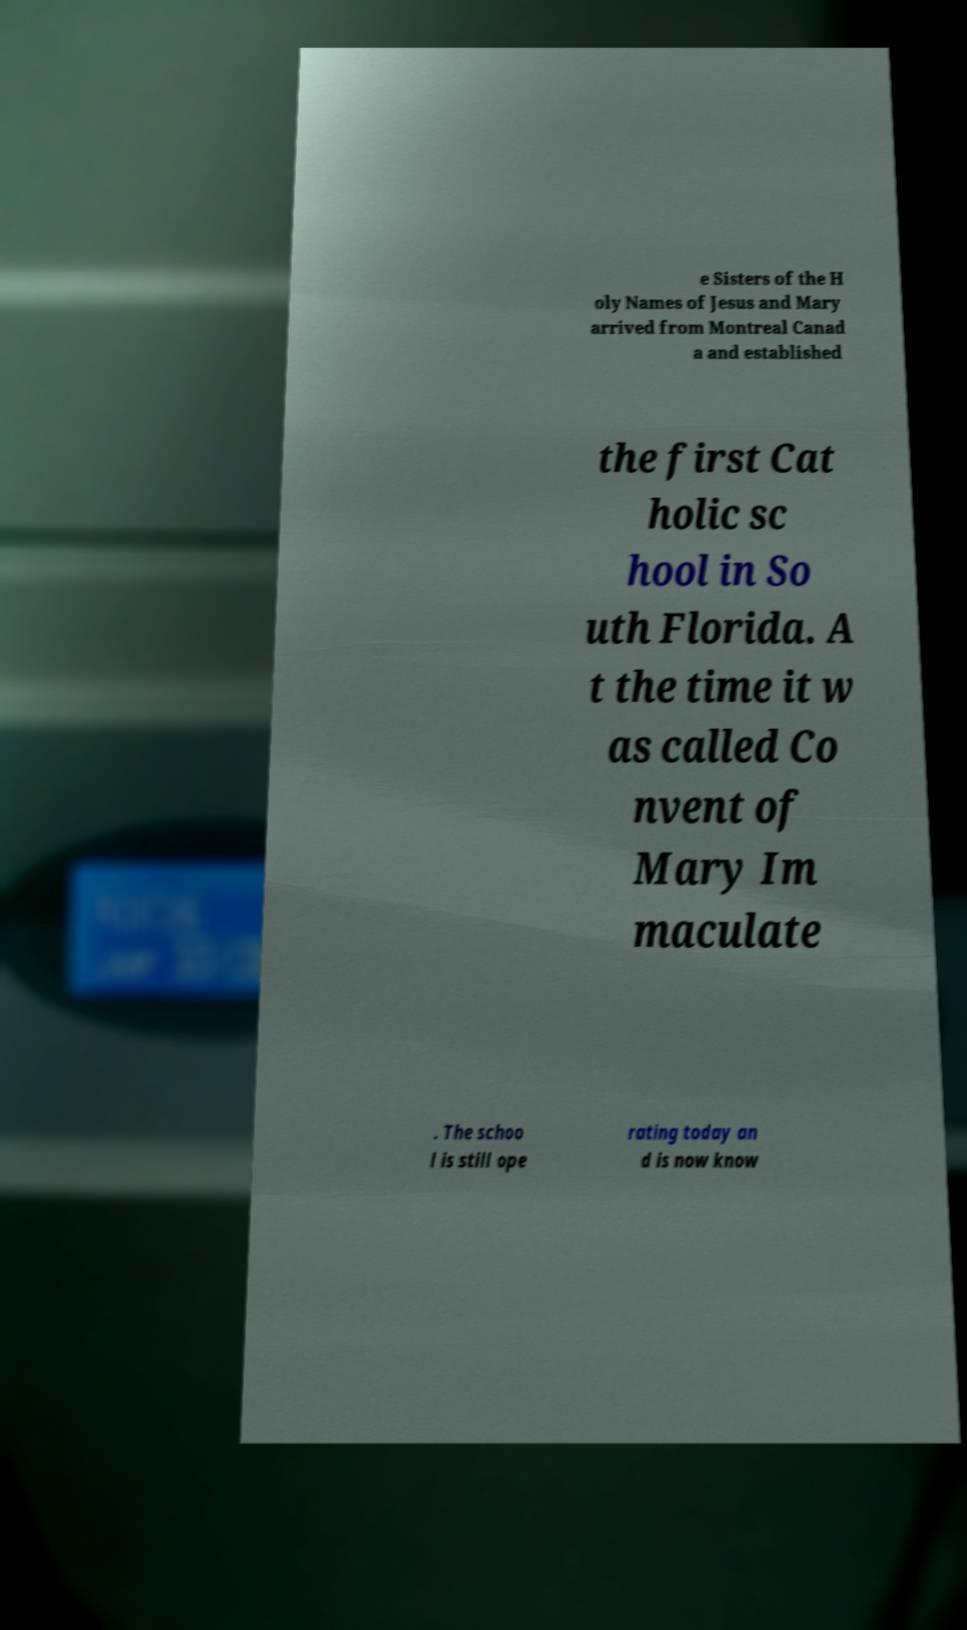Could you assist in decoding the text presented in this image and type it out clearly? e Sisters of the H oly Names of Jesus and Mary arrived from Montreal Canad a and established the first Cat holic sc hool in So uth Florida. A t the time it w as called Co nvent of Mary Im maculate . The schoo l is still ope rating today an d is now know 